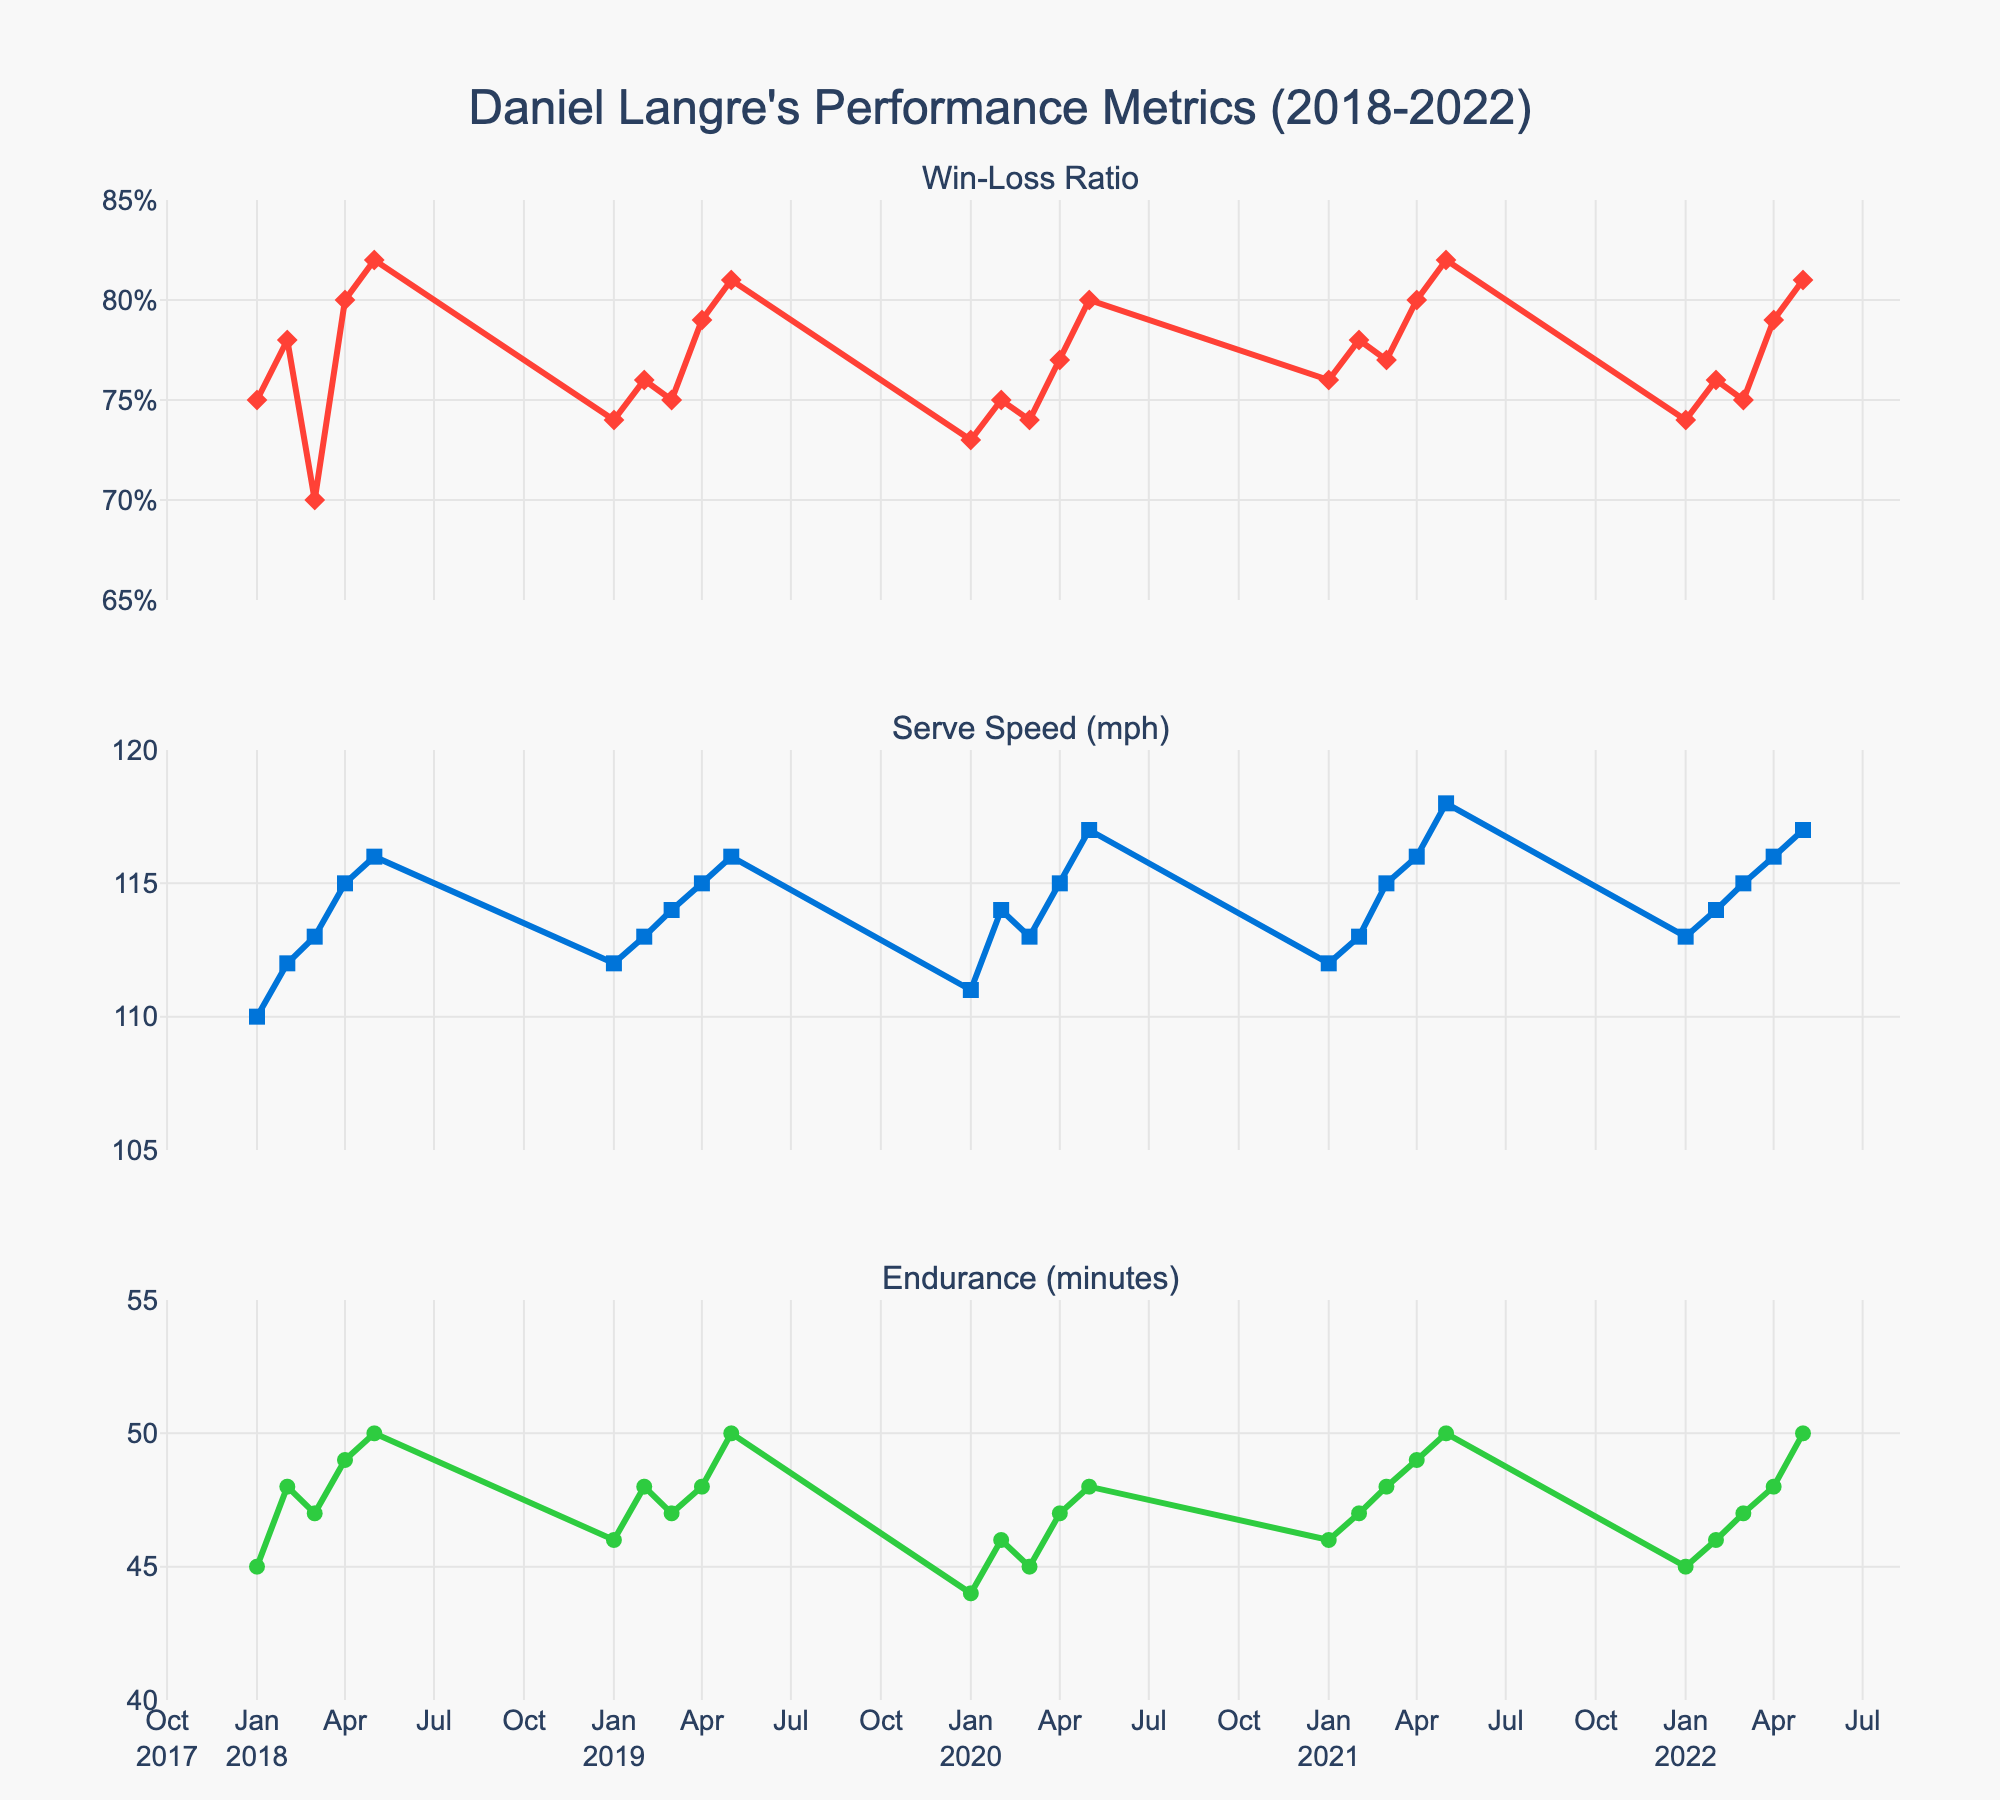What is the title of the figure? The title is displayed at the top of the figure and typically gives a summary of what the figure represents. In this case, it refers to the title text at the top.
Answer: Daniel Langre's Performance Metrics (2018-2022) What is the win-loss ratio in January 2019? To find this, locate the data point on the Win-Loss Ratio subplot that corresponds to January 2019. The x-axis plots the dates and the y-axis shows the win-loss ratio values.
Answer: 0.74 By how much did Daniel Langre's serve speed increase from January 2018 to May 2018? First, locate the serve speeds in January 2018 and May 2018 on the Serve Speed subplot. Subtract the January value from the May value. Serve speeds: January 2018 = 110 mph, May 2018 = 116 mph. So, 116 - 110 = 6 mph.
Answer: 6 mph Which month and year did Daniel Langre achieve his highest endurance? On the Endurance subplot, identify the highest point on the y-axis, and note the corresponding date on the x-axis. The highest endurance value on the y-axis corresponds to 50 minutes.
Answer: May 2018, May 2019, May 2021, or May 2022 Compare Daniel Langre's average win-loss ratio in 2018 and 2021. First, find the win-loss ratios for each month in 2018 and 2021. Then calculate the average for each year. 2018: (0.75 + 0.78 + 0.70 + 0.80 + 0.82) / 5 = 0.77. 2021: (0.76 + 0.78 + 0.77 + 0.80 + 0.82) / 5 = 0.79.
Answer: 0.77 (2018) and 0.79 (2021) Does Daniel Langre's endurance tend to increase over the months within each year? Observe the slope of the lines within each year on the Endurance subplot. Generally, if the endurance values go up as the months progress, it's an increase. Starting from January to May of each year, endurance values generally increase, indicating a trend.
Answer: Yes, it tends to increase What is the trend in win-loss ratio from 2020 to 2022? Look at the Win-Loss Ratio subplot and observe the overall direction of the data points from 2020 to 2022. The trend is the general direction of these points. The win-loss ratio shows a slight increase over the years.
Answer: Increasing trend 